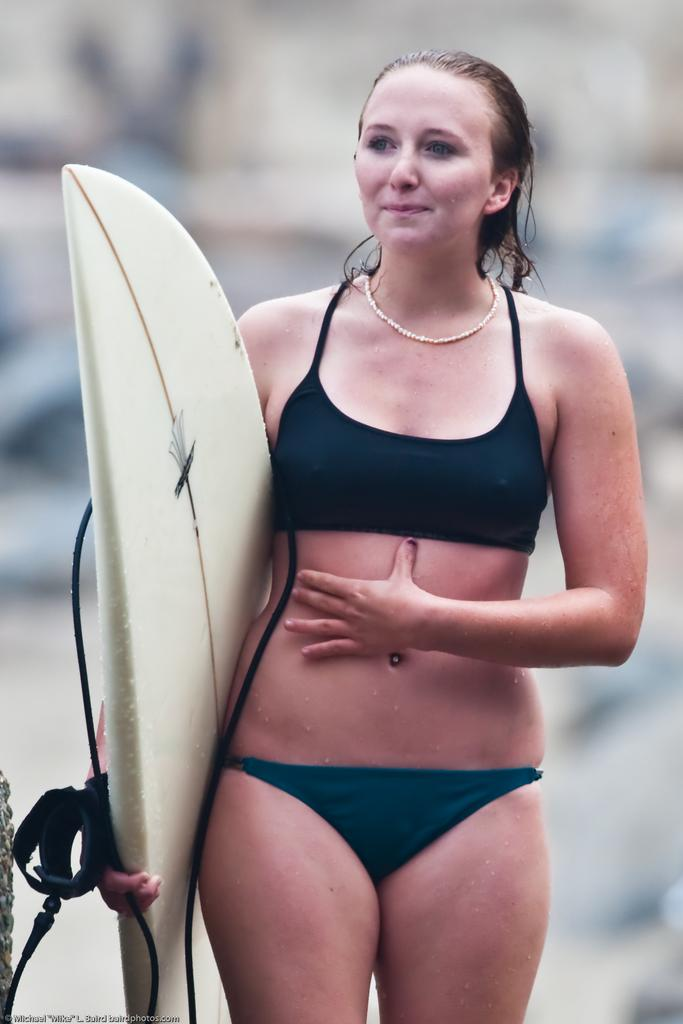What is there is a person in the image, what is the person doing? The person in the image is standing. What is the person holding in her hand? The person is holding a white-colored water skateboard in her hand. What type of curtain is hanging in the background of the image? There is no curtain present in the image. What type of trousers is the person wearing in the image? The provided facts do not mention the type of trousers the person is wearing. Is there a slave depicted in the image? There is no mention of a slave or any form of slavery in the image. 